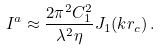<formula> <loc_0><loc_0><loc_500><loc_500>I ^ { a } \approx \frac { 2 \pi ^ { 2 } C _ { 1 } ^ { 2 } } { \lambda ^ { 2 } \eta } J _ { 1 } ( k r _ { c } ) \, .</formula> 